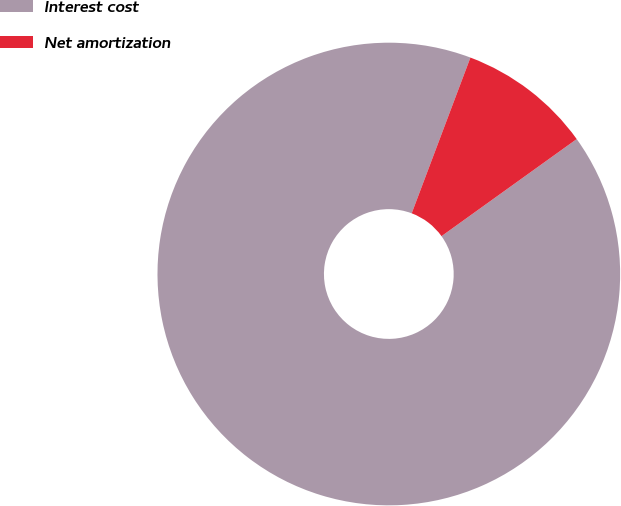<chart> <loc_0><loc_0><loc_500><loc_500><pie_chart><fcel>Interest cost<fcel>Net amortization<nl><fcel>90.65%<fcel>9.35%<nl></chart> 